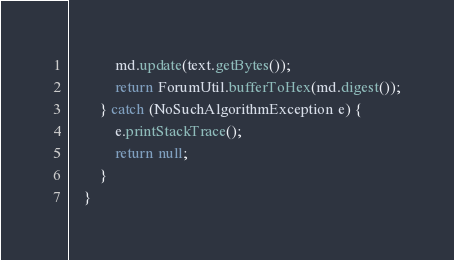Convert code to text. <code><loc_0><loc_0><loc_500><loc_500><_Java_>            md.update(text.getBytes());
            return ForumUtil.bufferToHex(md.digest());
        } catch (NoSuchAlgorithmException e) {
            e.printStackTrace();
            return null;
        }
    }
</code> 